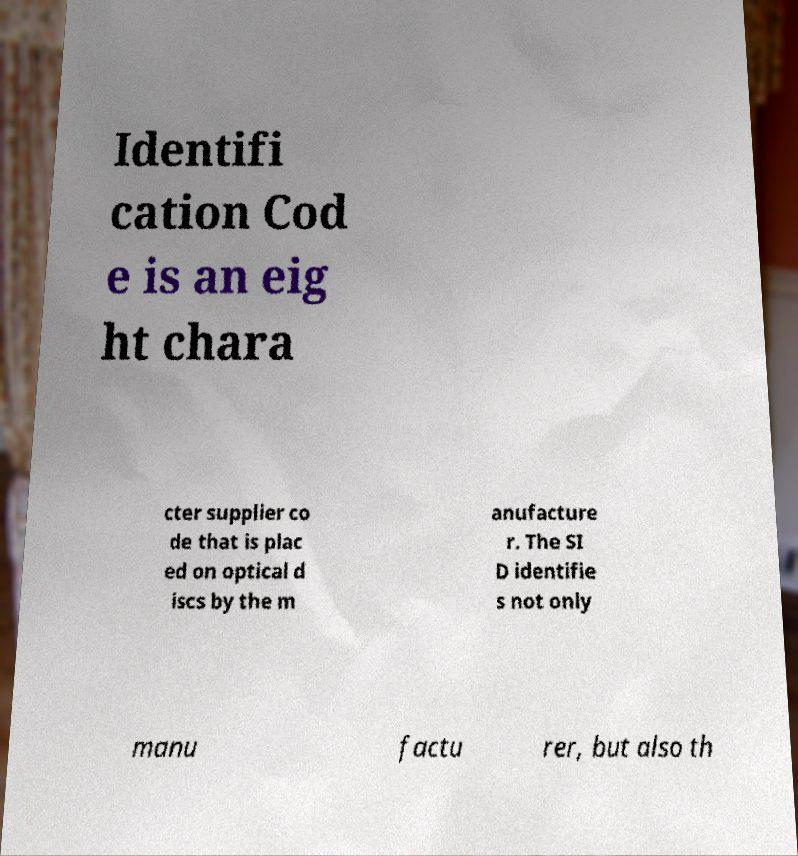For documentation purposes, I need the text within this image transcribed. Could you provide that? Identifi cation Cod e is an eig ht chara cter supplier co de that is plac ed on optical d iscs by the m anufacture r. The SI D identifie s not only manu factu rer, but also th 